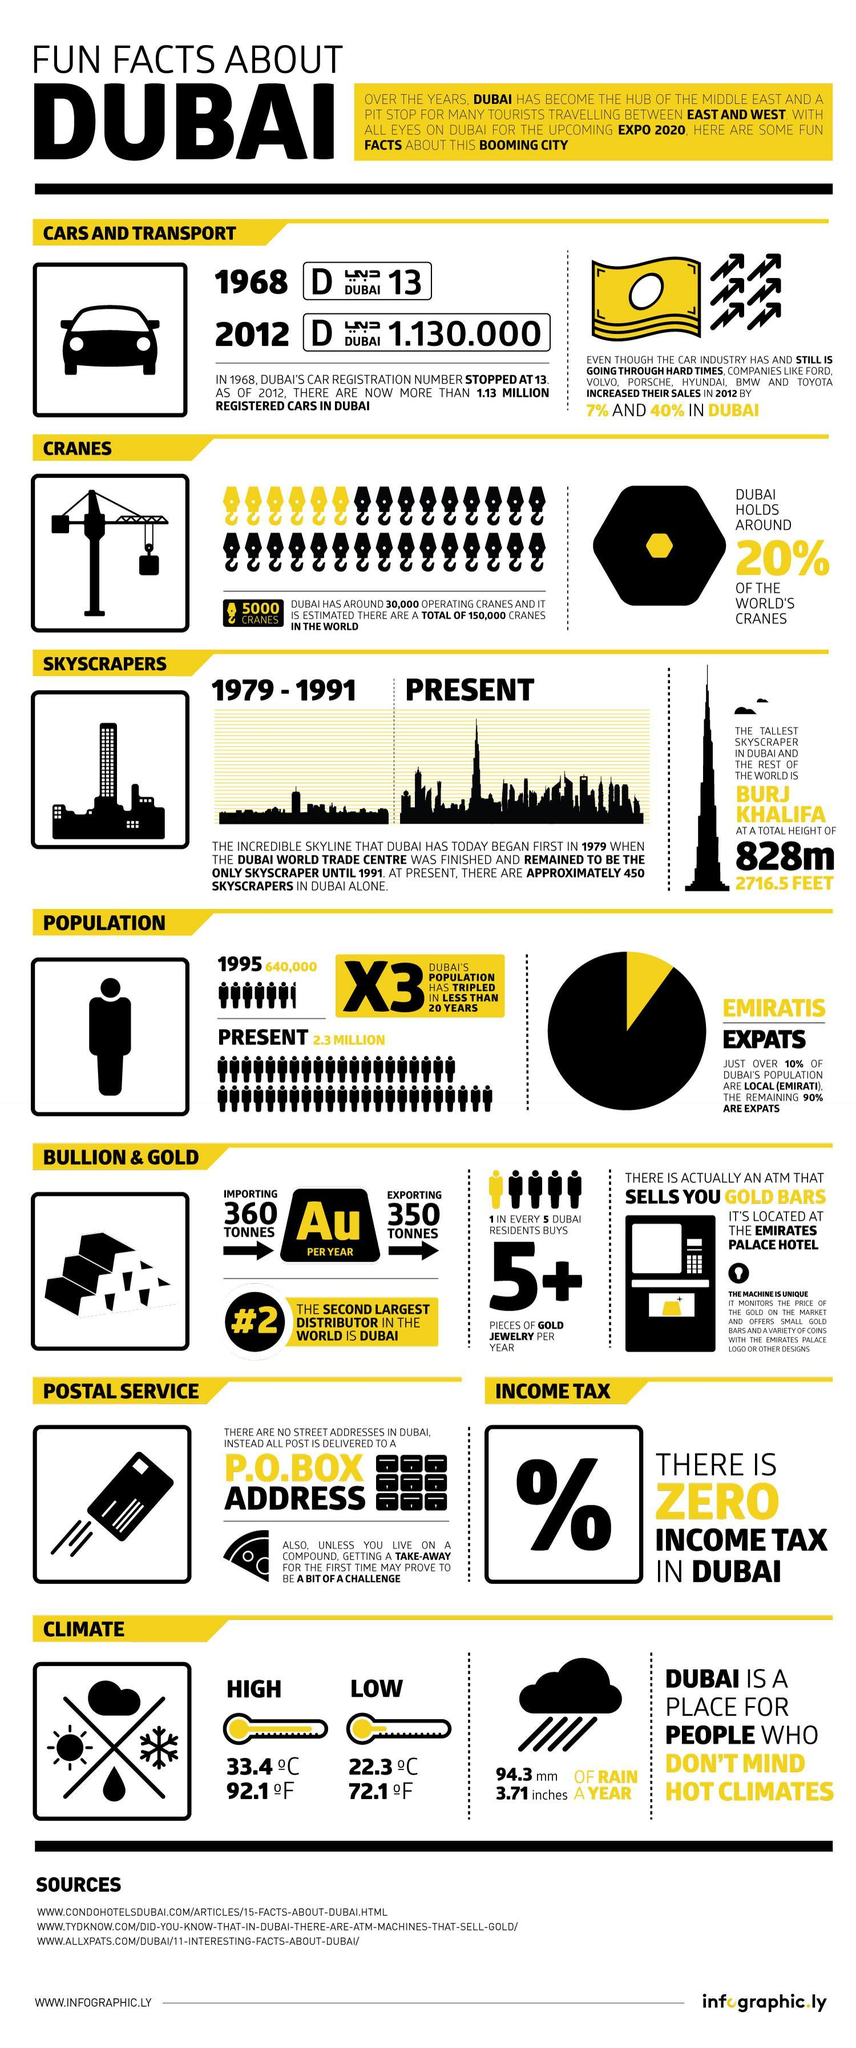How much amount of rain is received by Dubai in millimeters in a year?
Answer the question with a short phrase. 94.3 What percentage of the world's cranes is not hold by Dubai? 80% What is the height of Burj Khalifa in meters? 828m What is the highest temperature of Dubai in degrees celsius? 33.4 What is the lowset temperature of Dubai in degrees celsius? 22.3 